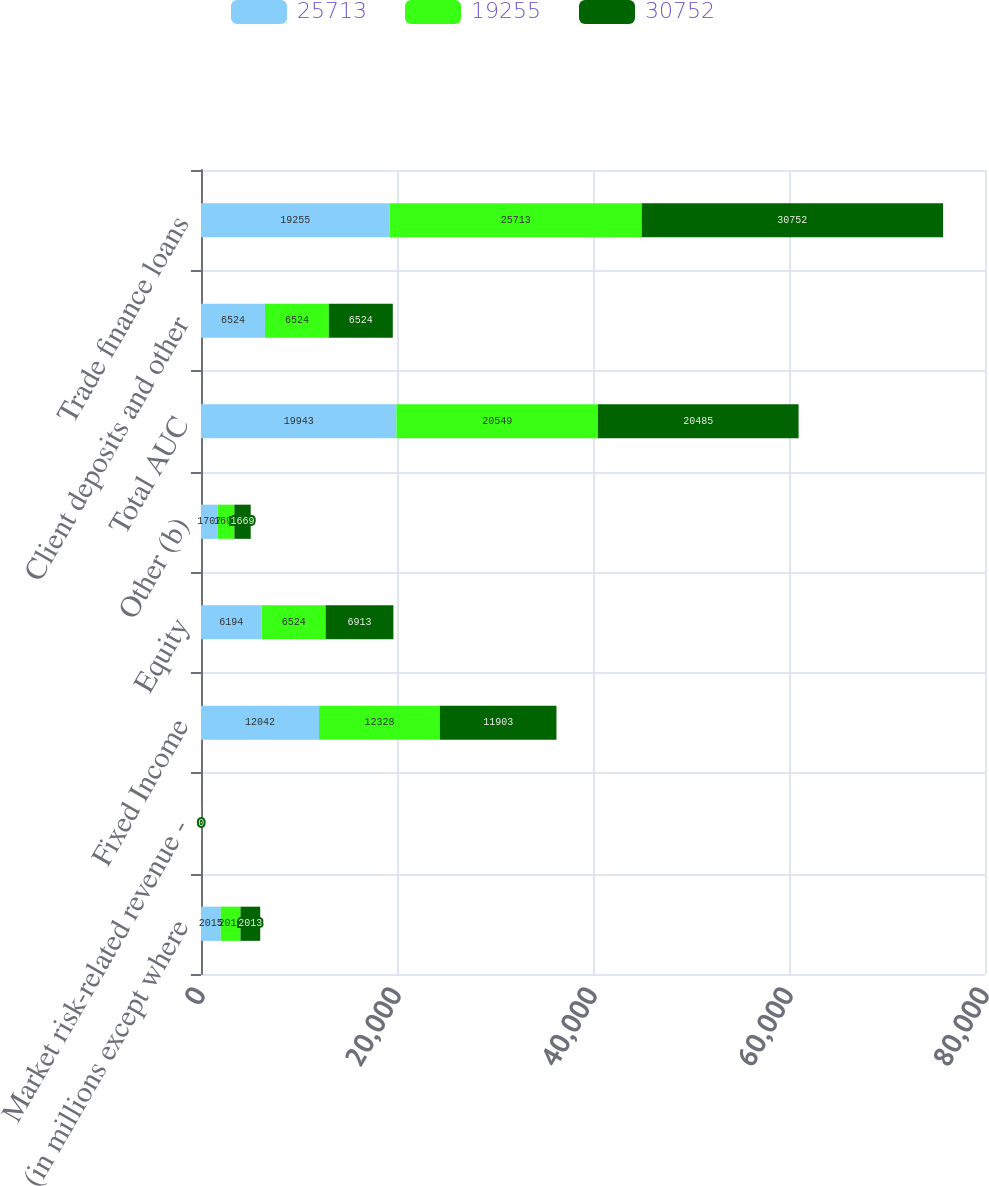Convert chart. <chart><loc_0><loc_0><loc_500><loc_500><stacked_bar_chart><ecel><fcel>(in millions except where<fcel>Market risk-related revenue -<fcel>Fixed Income<fcel>Equity<fcel>Other (b)<fcel>Total AUC<fcel>Client deposits and other<fcel>Trade finance loans<nl><fcel>25713<fcel>2015<fcel>9<fcel>12042<fcel>6194<fcel>1707<fcel>19943<fcel>6524<fcel>19255<nl><fcel>19255<fcel>2014<fcel>9<fcel>12328<fcel>6524<fcel>1697<fcel>20549<fcel>6524<fcel>25713<nl><fcel>30752<fcel>2013<fcel>0<fcel>11903<fcel>6913<fcel>1669<fcel>20485<fcel>6524<fcel>30752<nl></chart> 